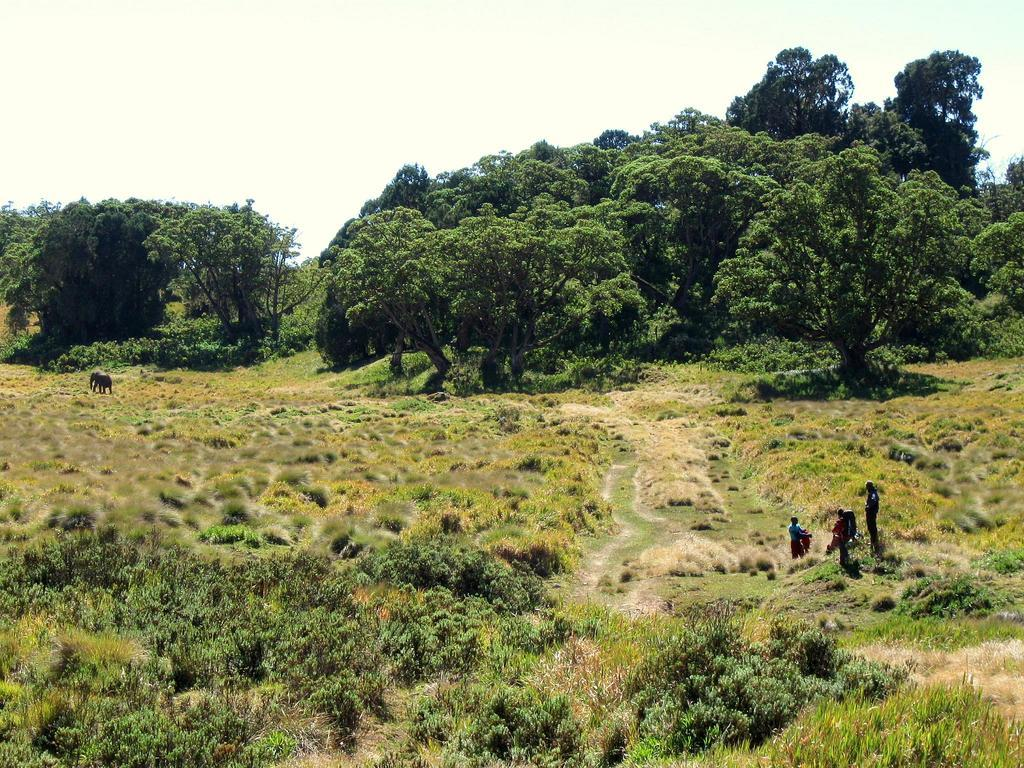What type of natural elements are present in the image? There are many plants and trees in the image. Can you describe the people on the right side of the image? There are three people on the right side of the image. What is the most prominent animal in the image? There is an elephant on the left side of the image. What type of star can be seen shining above the elephant in the image? There is no star visible in the image; it is focused on the plants, trees, people, and elephant. 